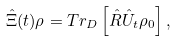Convert formula to latex. <formula><loc_0><loc_0><loc_500><loc_500>\hat { \Xi } ( t ) \rho = T r _ { D } \left [ \hat { R } \hat { U } _ { t } \rho _ { 0 } \right ] ,</formula> 